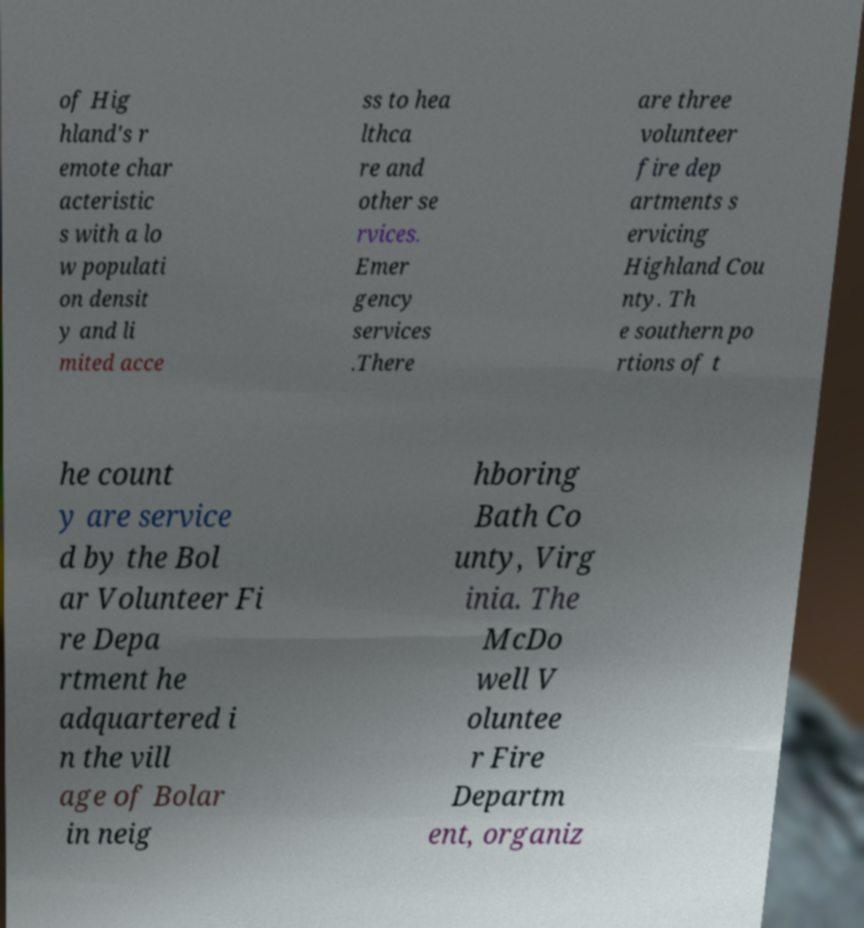Please identify and transcribe the text found in this image. of Hig hland's r emote char acteristic s with a lo w populati on densit y and li mited acce ss to hea lthca re and other se rvices. Emer gency services .There are three volunteer fire dep artments s ervicing Highland Cou nty. Th e southern po rtions of t he count y are service d by the Bol ar Volunteer Fi re Depa rtment he adquartered i n the vill age of Bolar in neig hboring Bath Co unty, Virg inia. The McDo well V oluntee r Fire Departm ent, organiz 